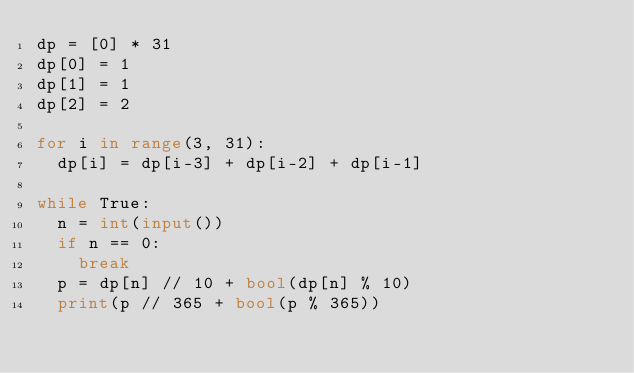Convert code to text. <code><loc_0><loc_0><loc_500><loc_500><_Python_>dp = [0] * 31
dp[0] = 1
dp[1] = 1
dp[2] = 2

for i in range(3, 31):
  dp[i] = dp[i-3] + dp[i-2] + dp[i-1]

while True:
  n = int(input())
  if n == 0:
    break
  p = dp[n] // 10 + bool(dp[n] % 10)
  print(p // 365 + bool(p % 365))
  
</code> 